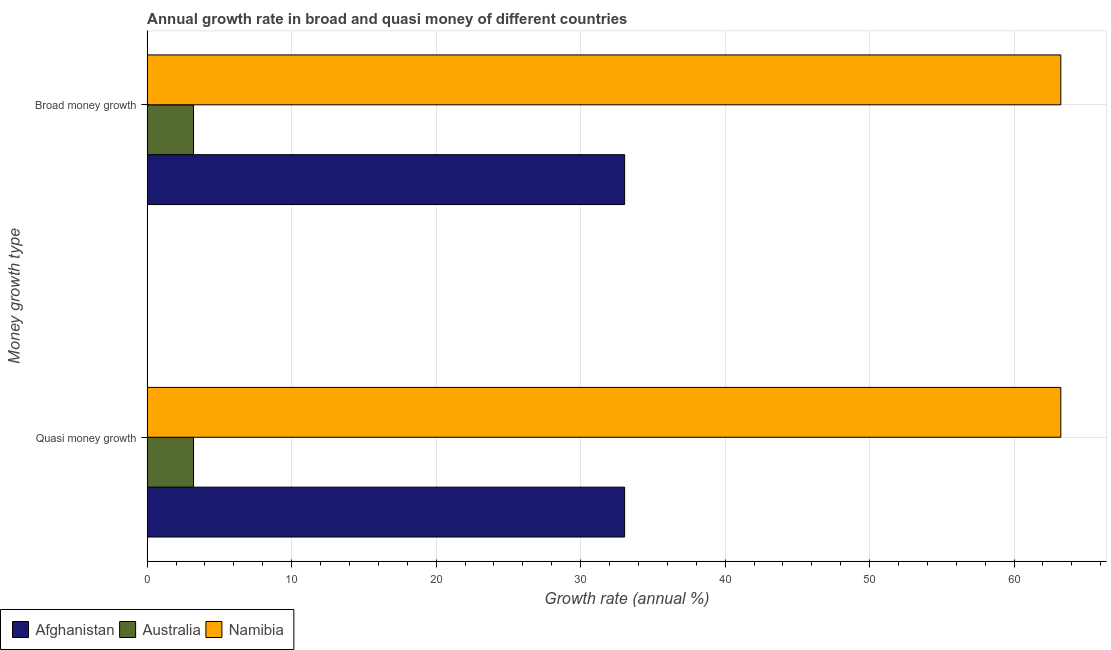Are the number of bars per tick equal to the number of legend labels?
Provide a short and direct response. Yes. How many bars are there on the 1st tick from the top?
Provide a succinct answer. 3. What is the label of the 2nd group of bars from the top?
Your response must be concise. Quasi money growth. What is the annual growth rate in broad money in Namibia?
Make the answer very short. 63.24. Across all countries, what is the maximum annual growth rate in broad money?
Provide a short and direct response. 63.24. Across all countries, what is the minimum annual growth rate in broad money?
Your answer should be very brief. 3.21. In which country was the annual growth rate in quasi money maximum?
Your answer should be very brief. Namibia. In which country was the annual growth rate in broad money minimum?
Your answer should be compact. Australia. What is the total annual growth rate in broad money in the graph?
Offer a very short reply. 99.49. What is the difference between the annual growth rate in broad money in Afghanistan and that in Namibia?
Your answer should be compact. -30.19. What is the difference between the annual growth rate in quasi money in Namibia and the annual growth rate in broad money in Australia?
Make the answer very short. 60.03. What is the average annual growth rate in broad money per country?
Provide a short and direct response. 33.16. In how many countries, is the annual growth rate in broad money greater than 12 %?
Give a very brief answer. 2. What is the ratio of the annual growth rate in quasi money in Namibia to that in Australia?
Your answer should be compact. 19.71. In how many countries, is the annual growth rate in quasi money greater than the average annual growth rate in quasi money taken over all countries?
Offer a terse response. 1. What does the 1st bar from the top in Quasi money growth represents?
Make the answer very short. Namibia. Are all the bars in the graph horizontal?
Your answer should be compact. Yes. How many countries are there in the graph?
Provide a short and direct response. 3. What is the difference between two consecutive major ticks on the X-axis?
Your answer should be compact. 10. Does the graph contain grids?
Your answer should be compact. Yes. What is the title of the graph?
Offer a very short reply. Annual growth rate in broad and quasi money of different countries. What is the label or title of the X-axis?
Make the answer very short. Growth rate (annual %). What is the label or title of the Y-axis?
Provide a succinct answer. Money growth type. What is the Growth rate (annual %) of Afghanistan in Quasi money growth?
Your response must be concise. 33.05. What is the Growth rate (annual %) in Australia in Quasi money growth?
Ensure brevity in your answer.  3.21. What is the Growth rate (annual %) of Namibia in Quasi money growth?
Provide a short and direct response. 63.24. What is the Growth rate (annual %) of Afghanistan in Broad money growth?
Provide a short and direct response. 33.05. What is the Growth rate (annual %) in Australia in Broad money growth?
Give a very brief answer. 3.21. What is the Growth rate (annual %) in Namibia in Broad money growth?
Provide a succinct answer. 63.24. Across all Money growth type, what is the maximum Growth rate (annual %) in Afghanistan?
Your answer should be compact. 33.05. Across all Money growth type, what is the maximum Growth rate (annual %) of Australia?
Offer a terse response. 3.21. Across all Money growth type, what is the maximum Growth rate (annual %) in Namibia?
Make the answer very short. 63.24. Across all Money growth type, what is the minimum Growth rate (annual %) in Afghanistan?
Offer a very short reply. 33.05. Across all Money growth type, what is the minimum Growth rate (annual %) in Australia?
Make the answer very short. 3.21. Across all Money growth type, what is the minimum Growth rate (annual %) in Namibia?
Offer a terse response. 63.24. What is the total Growth rate (annual %) of Afghanistan in the graph?
Provide a succinct answer. 66.09. What is the total Growth rate (annual %) of Australia in the graph?
Your answer should be compact. 6.42. What is the total Growth rate (annual %) in Namibia in the graph?
Give a very brief answer. 126.47. What is the difference between the Growth rate (annual %) of Afghanistan in Quasi money growth and that in Broad money growth?
Your answer should be very brief. 0. What is the difference between the Growth rate (annual %) of Afghanistan in Quasi money growth and the Growth rate (annual %) of Australia in Broad money growth?
Your answer should be compact. 29.84. What is the difference between the Growth rate (annual %) of Afghanistan in Quasi money growth and the Growth rate (annual %) of Namibia in Broad money growth?
Give a very brief answer. -30.19. What is the difference between the Growth rate (annual %) of Australia in Quasi money growth and the Growth rate (annual %) of Namibia in Broad money growth?
Provide a short and direct response. -60.03. What is the average Growth rate (annual %) in Afghanistan per Money growth type?
Offer a terse response. 33.05. What is the average Growth rate (annual %) of Australia per Money growth type?
Your answer should be compact. 3.21. What is the average Growth rate (annual %) in Namibia per Money growth type?
Offer a terse response. 63.24. What is the difference between the Growth rate (annual %) of Afghanistan and Growth rate (annual %) of Australia in Quasi money growth?
Give a very brief answer. 29.84. What is the difference between the Growth rate (annual %) of Afghanistan and Growth rate (annual %) of Namibia in Quasi money growth?
Your answer should be very brief. -30.19. What is the difference between the Growth rate (annual %) of Australia and Growth rate (annual %) of Namibia in Quasi money growth?
Make the answer very short. -60.03. What is the difference between the Growth rate (annual %) of Afghanistan and Growth rate (annual %) of Australia in Broad money growth?
Make the answer very short. 29.84. What is the difference between the Growth rate (annual %) of Afghanistan and Growth rate (annual %) of Namibia in Broad money growth?
Your response must be concise. -30.19. What is the difference between the Growth rate (annual %) of Australia and Growth rate (annual %) of Namibia in Broad money growth?
Provide a succinct answer. -60.03. What is the ratio of the Growth rate (annual %) of Afghanistan in Quasi money growth to that in Broad money growth?
Your response must be concise. 1. What is the ratio of the Growth rate (annual %) in Australia in Quasi money growth to that in Broad money growth?
Provide a short and direct response. 1. What is the difference between the highest and the second highest Growth rate (annual %) of Afghanistan?
Keep it short and to the point. 0. What is the difference between the highest and the second highest Growth rate (annual %) of Australia?
Provide a succinct answer. 0. What is the difference between the highest and the lowest Growth rate (annual %) in Australia?
Provide a short and direct response. 0. What is the difference between the highest and the lowest Growth rate (annual %) of Namibia?
Your answer should be compact. 0. 